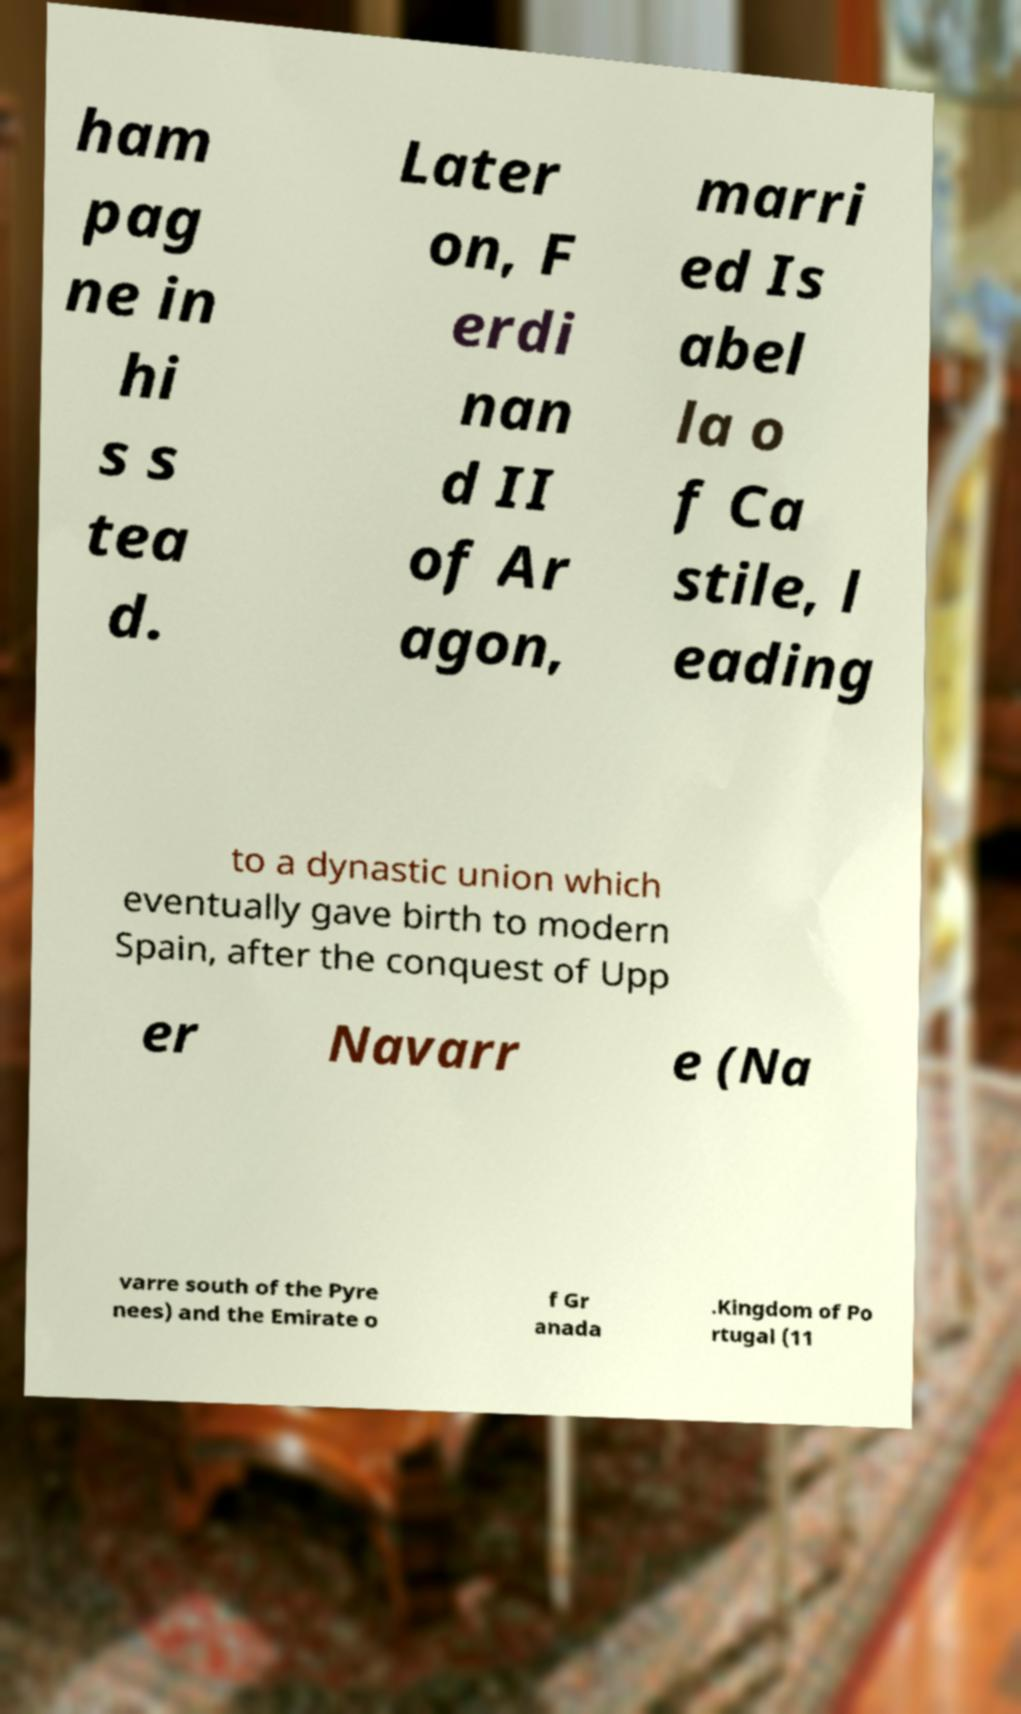Could you assist in decoding the text presented in this image and type it out clearly? ham pag ne in hi s s tea d. Later on, F erdi nan d II of Ar agon, marri ed Is abel la o f Ca stile, l eading to a dynastic union which eventually gave birth to modern Spain, after the conquest of Upp er Navarr e (Na varre south of the Pyre nees) and the Emirate o f Gr anada .Kingdom of Po rtugal (11 